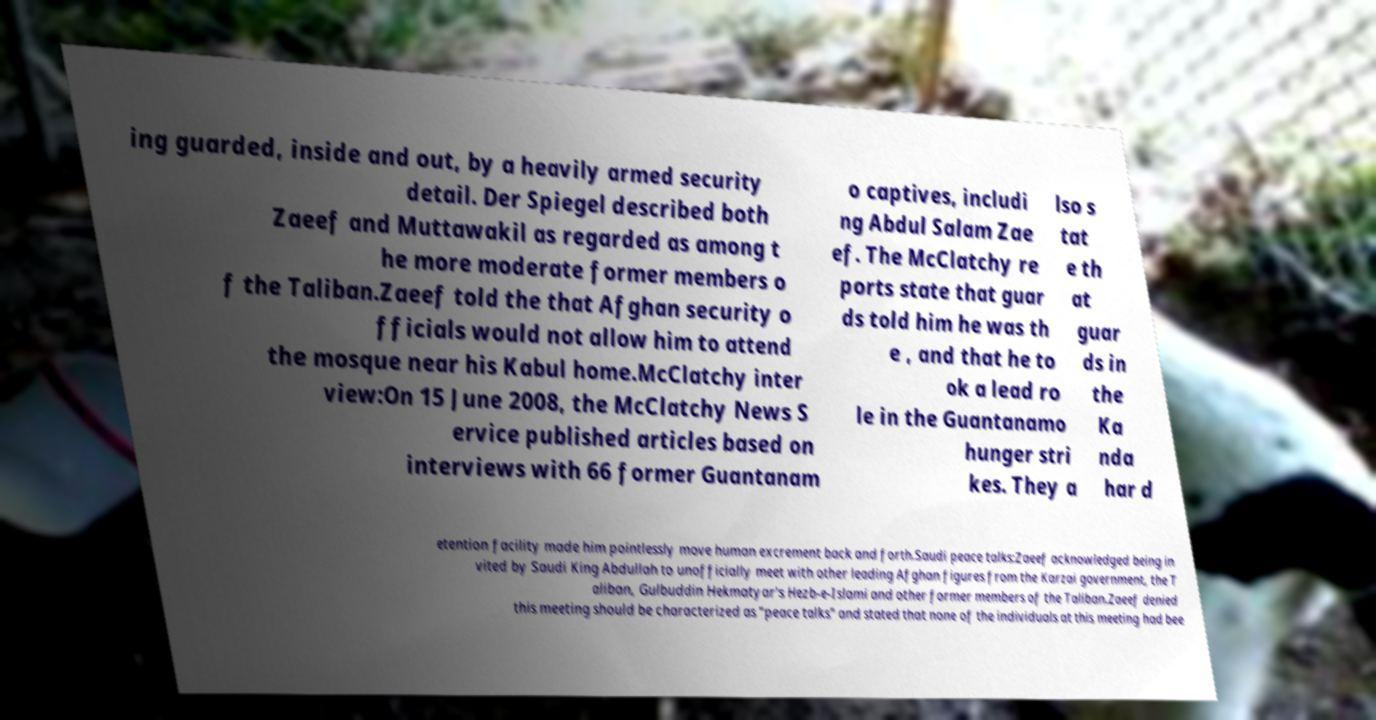I need the written content from this picture converted into text. Can you do that? ing guarded, inside and out, by a heavily armed security detail. Der Spiegel described both Zaeef and Muttawakil as regarded as among t he more moderate former members o f the Taliban.Zaeef told the that Afghan security o fficials would not allow him to attend the mosque near his Kabul home.McClatchy inter view:On 15 June 2008, the McClatchy News S ervice published articles based on interviews with 66 former Guantanam o captives, includi ng Abdul Salam Zae ef. The McClatchy re ports state that guar ds told him he was th e , and that he to ok a lead ro le in the Guantanamo hunger stri kes. They a lso s tat e th at guar ds in the Ka nda har d etention facility made him pointlessly move human excrement back and forth.Saudi peace talks:Zaeef acknowledged being in vited by Saudi King Abdullah to unofficially meet with other leading Afghan figures from the Karzai government, the T aliban, Gulbuddin Hekmatyar's Hezb-e-Islami and other former members of the Taliban.Zaeef denied this meeting should be characterized as "peace talks" and stated that none of the individuals at this meeting had bee 